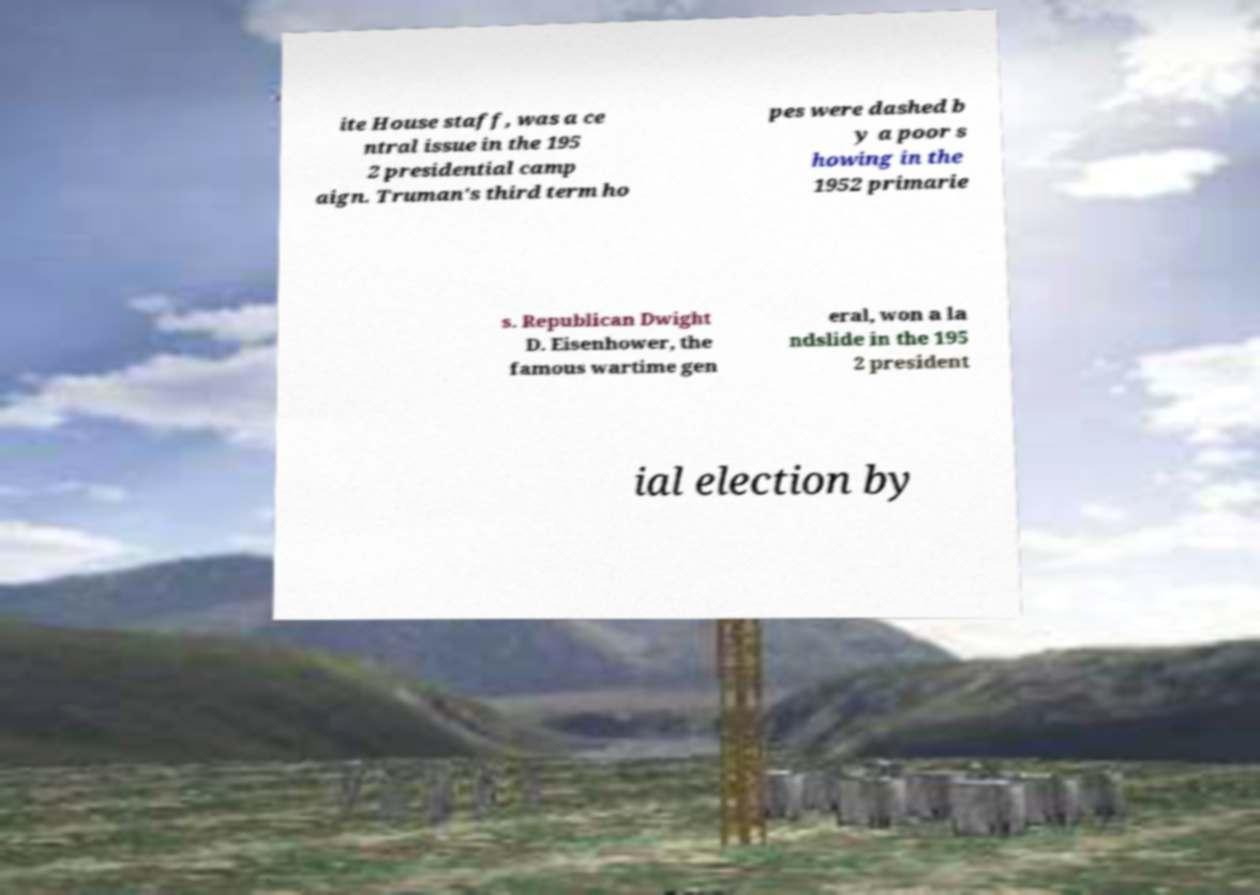Can you accurately transcribe the text from the provided image for me? ite House staff, was a ce ntral issue in the 195 2 presidential camp aign. Truman's third term ho pes were dashed b y a poor s howing in the 1952 primarie s. Republican Dwight D. Eisenhower, the famous wartime gen eral, won a la ndslide in the 195 2 president ial election by 